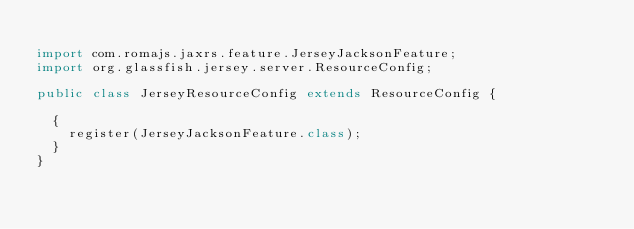Convert code to text. <code><loc_0><loc_0><loc_500><loc_500><_Java_>
import com.romajs.jaxrs.feature.JerseyJacksonFeature;
import org.glassfish.jersey.server.ResourceConfig;

public class JerseyResourceConfig extends ResourceConfig {

	{
		register(JerseyJacksonFeature.class);
	}
}
</code> 